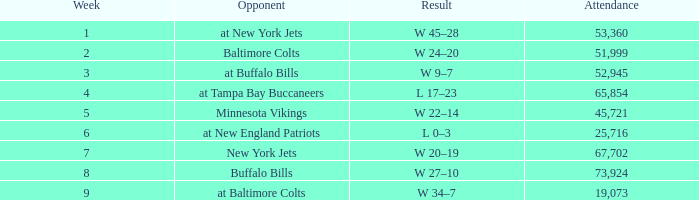What is the result of the game with an attendance greater than 67,702? W 27–10. 